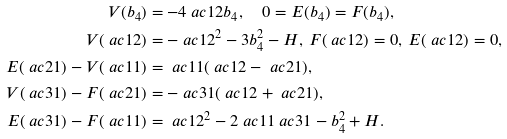Convert formula to latex. <formula><loc_0><loc_0><loc_500><loc_500>V ( b _ { 4 } ) & = - 4 \ a c 1 2 b _ { 4 } , \quad 0 = E ( b _ { 4 } ) = F ( b _ { 4 } ) , \\ V ( \ a c 1 2 ) & = - \ a c 1 2 ^ { 2 } - 3 b _ { 4 } ^ { 2 } - H , \, F ( \ a c 1 2 ) = 0 , \, E ( \ a c 1 2 ) = 0 , \\ E ( \ a c 2 1 ) - V ( \ a c 1 1 ) & = \ a c 1 1 ( \ a c 1 2 - \ a c 2 1 ) , \\ V ( \ a c 3 1 ) - F ( \ a c 2 1 ) & = - \ a c 3 1 ( \ a c 1 2 + \ a c 2 1 ) , \\ E ( \ a c 3 1 ) - F ( \ a c 1 1 ) & = \ a c 1 2 ^ { 2 } - 2 \ a c 1 1 \ a c 3 1 - b _ { 4 } ^ { 2 } + H .</formula> 